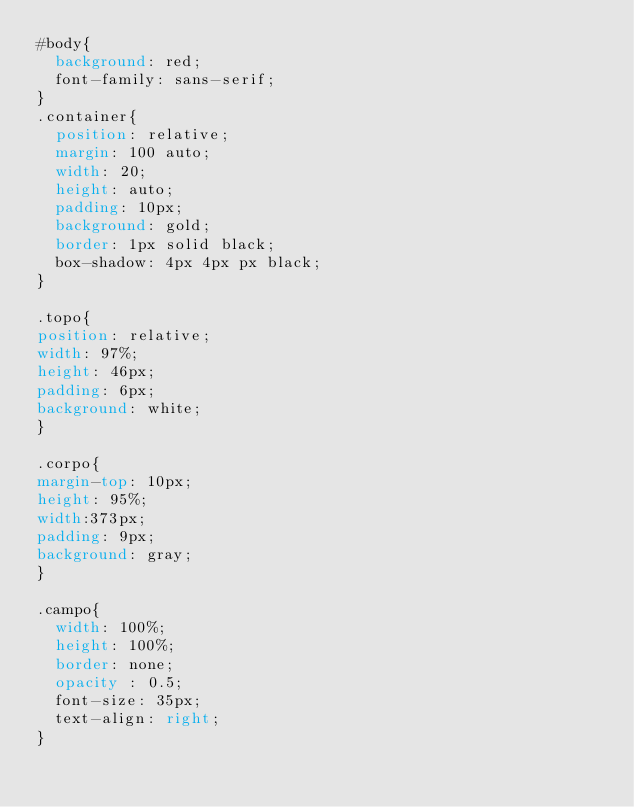<code> <loc_0><loc_0><loc_500><loc_500><_CSS_>#body{
  background: red;
  font-family: sans-serif;
}
.container{
  position: relative;
  margin: 100 auto;
  width: 20;
  height: auto;
  padding: 10px;
  background: gold;
  border: 1px solid black;
  box-shadow: 4px 4px px black;
}

.topo{
position: relative;
width: 97%;
height: 46px;
padding: 6px;
background: white;
}

.corpo{
margin-top: 10px;
height: 95%;
width:373px;
padding: 9px;
background: gray;
}

.campo{
  width: 100%;
  height: 100%;
  border: none;
  opacity : 0.5;
  font-size: 35px;
  text-align: right;
}</code> 